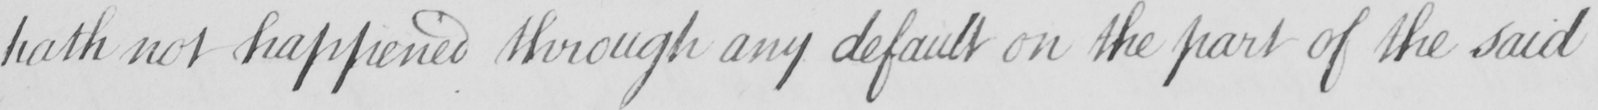Please provide the text content of this handwritten line. hath not happened through any default on the part of the said 